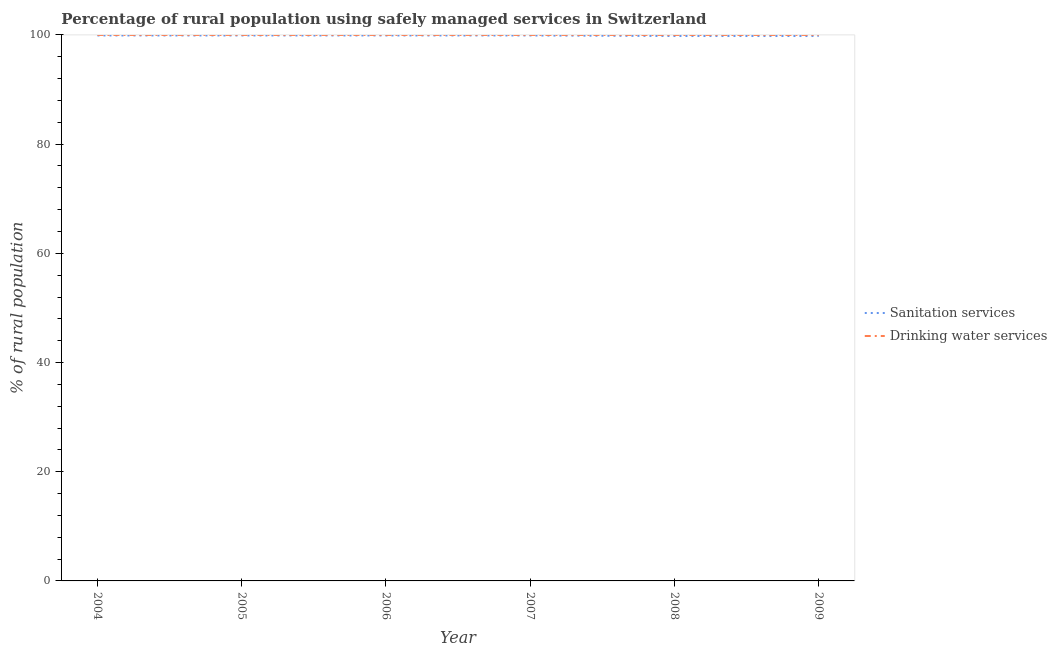Is the number of lines equal to the number of legend labels?
Your response must be concise. Yes. What is the percentage of rural population who used drinking water services in 2009?
Your response must be concise. 100. Across all years, what is the maximum percentage of rural population who used drinking water services?
Keep it short and to the point. 100. Across all years, what is the minimum percentage of rural population who used sanitation services?
Offer a terse response. 99.8. In which year was the percentage of rural population who used drinking water services maximum?
Give a very brief answer. 2004. In which year was the percentage of rural population who used sanitation services minimum?
Provide a short and direct response. 2008. What is the total percentage of rural population who used drinking water services in the graph?
Your answer should be compact. 600. What is the difference between the percentage of rural population who used sanitation services in 2005 and that in 2008?
Provide a short and direct response. 0.1. What is the difference between the percentage of rural population who used sanitation services in 2006 and the percentage of rural population who used drinking water services in 2008?
Provide a succinct answer. -0.1. What is the average percentage of rural population who used drinking water services per year?
Your answer should be very brief. 100. In the year 2007, what is the difference between the percentage of rural population who used sanitation services and percentage of rural population who used drinking water services?
Your answer should be very brief. -0.1. In how many years, is the percentage of rural population who used drinking water services greater than 64 %?
Ensure brevity in your answer.  6. Is the difference between the percentage of rural population who used drinking water services in 2006 and 2008 greater than the difference between the percentage of rural population who used sanitation services in 2006 and 2008?
Ensure brevity in your answer.  No. What is the difference between the highest and the second highest percentage of rural population who used sanitation services?
Your answer should be compact. 0. What is the difference between the highest and the lowest percentage of rural population who used sanitation services?
Provide a succinct answer. 0.1. Is the sum of the percentage of rural population who used drinking water services in 2005 and 2007 greater than the maximum percentage of rural population who used sanitation services across all years?
Your response must be concise. Yes. Is the percentage of rural population who used sanitation services strictly greater than the percentage of rural population who used drinking water services over the years?
Give a very brief answer. No. Is the percentage of rural population who used drinking water services strictly less than the percentage of rural population who used sanitation services over the years?
Your answer should be very brief. No. What is the difference between two consecutive major ticks on the Y-axis?
Your answer should be very brief. 20. Are the values on the major ticks of Y-axis written in scientific E-notation?
Offer a very short reply. No. Where does the legend appear in the graph?
Offer a terse response. Center right. How many legend labels are there?
Your answer should be compact. 2. What is the title of the graph?
Your response must be concise. Percentage of rural population using safely managed services in Switzerland. Does "Male population" appear as one of the legend labels in the graph?
Provide a short and direct response. No. What is the label or title of the X-axis?
Offer a terse response. Year. What is the label or title of the Y-axis?
Your response must be concise. % of rural population. What is the % of rural population in Sanitation services in 2004?
Offer a terse response. 99.9. What is the % of rural population of Sanitation services in 2005?
Offer a very short reply. 99.9. What is the % of rural population of Sanitation services in 2006?
Keep it short and to the point. 99.9. What is the % of rural population in Drinking water services in 2006?
Your answer should be compact. 100. What is the % of rural population in Sanitation services in 2007?
Keep it short and to the point. 99.9. What is the % of rural population in Drinking water services in 2007?
Provide a short and direct response. 100. What is the % of rural population in Sanitation services in 2008?
Ensure brevity in your answer.  99.8. What is the % of rural population in Sanitation services in 2009?
Offer a very short reply. 99.8. What is the % of rural population in Drinking water services in 2009?
Provide a short and direct response. 100. Across all years, what is the maximum % of rural population in Sanitation services?
Ensure brevity in your answer.  99.9. Across all years, what is the minimum % of rural population of Sanitation services?
Your answer should be compact. 99.8. Across all years, what is the minimum % of rural population in Drinking water services?
Make the answer very short. 100. What is the total % of rural population in Sanitation services in the graph?
Provide a short and direct response. 599.2. What is the total % of rural population in Drinking water services in the graph?
Keep it short and to the point. 600. What is the difference between the % of rural population of Sanitation services in 2004 and that in 2006?
Your answer should be very brief. 0. What is the difference between the % of rural population of Drinking water services in 2004 and that in 2006?
Make the answer very short. 0. What is the difference between the % of rural population of Drinking water services in 2004 and that in 2008?
Provide a short and direct response. 0. What is the difference between the % of rural population of Sanitation services in 2004 and that in 2009?
Offer a very short reply. 0.1. What is the difference between the % of rural population of Sanitation services in 2005 and that in 2007?
Offer a very short reply. 0. What is the difference between the % of rural population in Drinking water services in 2005 and that in 2008?
Your answer should be very brief. 0. What is the difference between the % of rural population in Sanitation services in 2006 and that in 2007?
Make the answer very short. 0. What is the difference between the % of rural population in Drinking water services in 2006 and that in 2007?
Keep it short and to the point. 0. What is the difference between the % of rural population of Sanitation services in 2006 and that in 2008?
Give a very brief answer. 0.1. What is the difference between the % of rural population of Drinking water services in 2006 and that in 2009?
Give a very brief answer. 0. What is the difference between the % of rural population of Sanitation services in 2007 and that in 2008?
Keep it short and to the point. 0.1. What is the difference between the % of rural population in Drinking water services in 2007 and that in 2008?
Your response must be concise. 0. What is the difference between the % of rural population in Sanitation services in 2007 and that in 2009?
Provide a short and direct response. 0.1. What is the difference between the % of rural population of Drinking water services in 2007 and that in 2009?
Your answer should be compact. 0. What is the difference between the % of rural population of Sanitation services in 2004 and the % of rural population of Drinking water services in 2005?
Provide a short and direct response. -0.1. What is the difference between the % of rural population of Sanitation services in 2004 and the % of rural population of Drinking water services in 2006?
Your answer should be compact. -0.1. What is the difference between the % of rural population of Sanitation services in 2004 and the % of rural population of Drinking water services in 2008?
Your answer should be compact. -0.1. What is the difference between the % of rural population in Sanitation services in 2005 and the % of rural population in Drinking water services in 2006?
Offer a very short reply. -0.1. What is the difference between the % of rural population in Sanitation services in 2005 and the % of rural population in Drinking water services in 2007?
Offer a terse response. -0.1. What is the difference between the % of rural population of Sanitation services in 2005 and the % of rural population of Drinking water services in 2008?
Give a very brief answer. -0.1. What is the difference between the % of rural population of Sanitation services in 2006 and the % of rural population of Drinking water services in 2007?
Give a very brief answer. -0.1. What is the difference between the % of rural population of Sanitation services in 2006 and the % of rural population of Drinking water services in 2008?
Keep it short and to the point. -0.1. What is the difference between the % of rural population of Sanitation services in 2006 and the % of rural population of Drinking water services in 2009?
Your response must be concise. -0.1. What is the difference between the % of rural population in Sanitation services in 2007 and the % of rural population in Drinking water services in 2008?
Give a very brief answer. -0.1. What is the average % of rural population in Sanitation services per year?
Make the answer very short. 99.87. In the year 2004, what is the difference between the % of rural population in Sanitation services and % of rural population in Drinking water services?
Keep it short and to the point. -0.1. In the year 2005, what is the difference between the % of rural population in Sanitation services and % of rural population in Drinking water services?
Make the answer very short. -0.1. In the year 2007, what is the difference between the % of rural population of Sanitation services and % of rural population of Drinking water services?
Offer a very short reply. -0.1. In the year 2009, what is the difference between the % of rural population in Sanitation services and % of rural population in Drinking water services?
Give a very brief answer. -0.2. What is the ratio of the % of rural population in Sanitation services in 2004 to that in 2007?
Make the answer very short. 1. What is the ratio of the % of rural population in Drinking water services in 2004 to that in 2007?
Keep it short and to the point. 1. What is the ratio of the % of rural population of Drinking water services in 2004 to that in 2008?
Provide a succinct answer. 1. What is the ratio of the % of rural population in Sanitation services in 2005 to that in 2006?
Give a very brief answer. 1. What is the ratio of the % of rural population in Drinking water services in 2005 to that in 2006?
Your answer should be compact. 1. What is the ratio of the % of rural population of Sanitation services in 2005 to that in 2009?
Ensure brevity in your answer.  1. What is the ratio of the % of rural population of Drinking water services in 2006 to that in 2008?
Ensure brevity in your answer.  1. What is the ratio of the % of rural population in Sanitation services in 2006 to that in 2009?
Make the answer very short. 1. What is the ratio of the % of rural population of Sanitation services in 2007 to that in 2008?
Provide a short and direct response. 1. What is the ratio of the % of rural population of Drinking water services in 2007 to that in 2008?
Your answer should be compact. 1. What is the ratio of the % of rural population in Sanitation services in 2007 to that in 2009?
Make the answer very short. 1. What is the ratio of the % of rural population in Drinking water services in 2007 to that in 2009?
Your answer should be very brief. 1. What is the ratio of the % of rural population of Drinking water services in 2008 to that in 2009?
Your answer should be compact. 1. What is the difference between the highest and the second highest % of rural population of Sanitation services?
Provide a short and direct response. 0. 